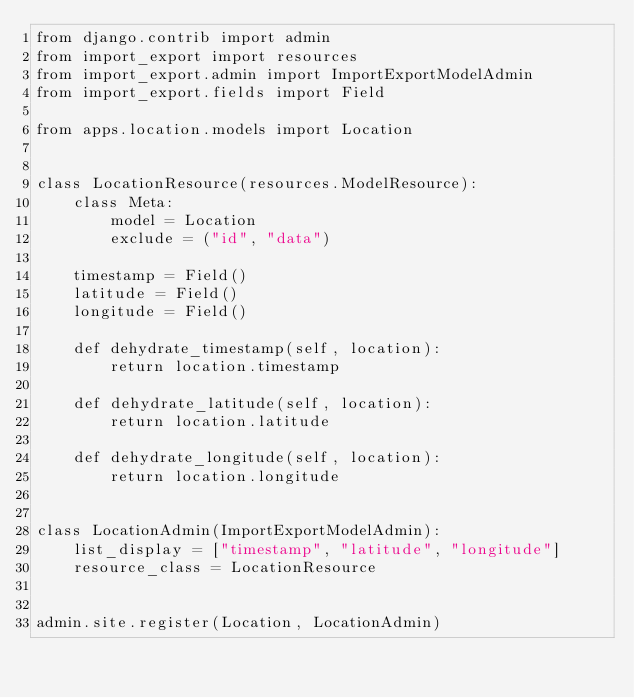<code> <loc_0><loc_0><loc_500><loc_500><_Python_>from django.contrib import admin
from import_export import resources
from import_export.admin import ImportExportModelAdmin
from import_export.fields import Field

from apps.location.models import Location


class LocationResource(resources.ModelResource):
    class Meta:
        model = Location
        exclude = ("id", "data")

    timestamp = Field()
    latitude = Field()
    longitude = Field()

    def dehydrate_timestamp(self, location):
        return location.timestamp

    def dehydrate_latitude(self, location):
        return location.latitude

    def dehydrate_longitude(self, location):
        return location.longitude


class LocationAdmin(ImportExportModelAdmin):
    list_display = ["timestamp", "latitude", "longitude"]
    resource_class = LocationResource


admin.site.register(Location, LocationAdmin)
</code> 